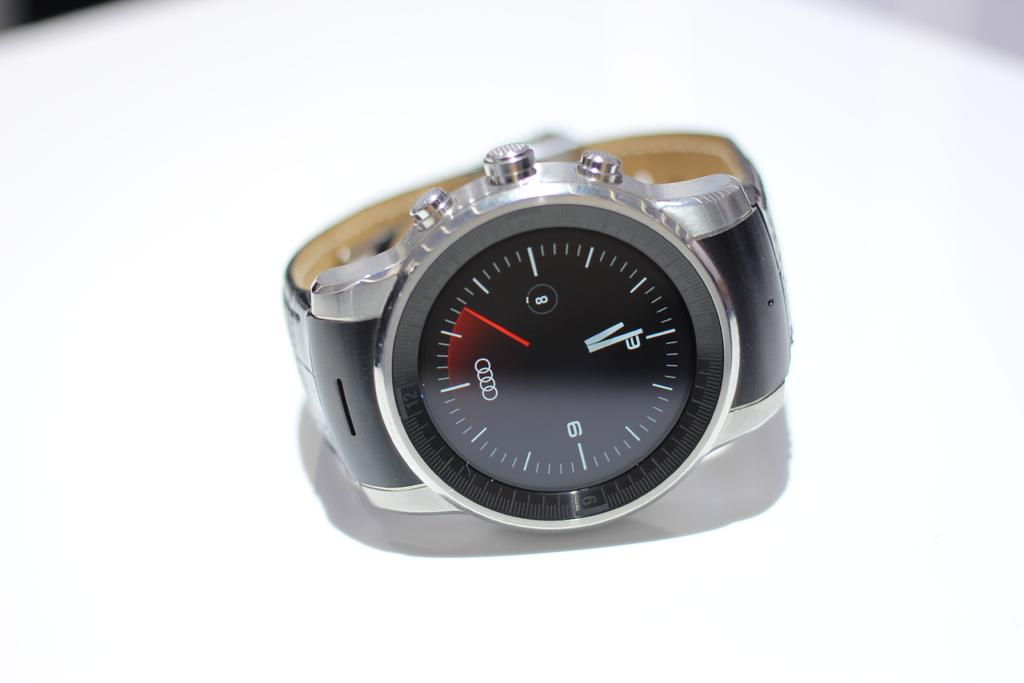What object is the main focus of the image? There is a watch in the image. Where is the watch located in relation to the image? The watch is in the center of the image. What is the color of the surface on which the watch is placed? The watch is on a white surface. Are there any plants growing near the watch in the image? There is no mention of plants in the image, so it cannot be determined if any are present. 